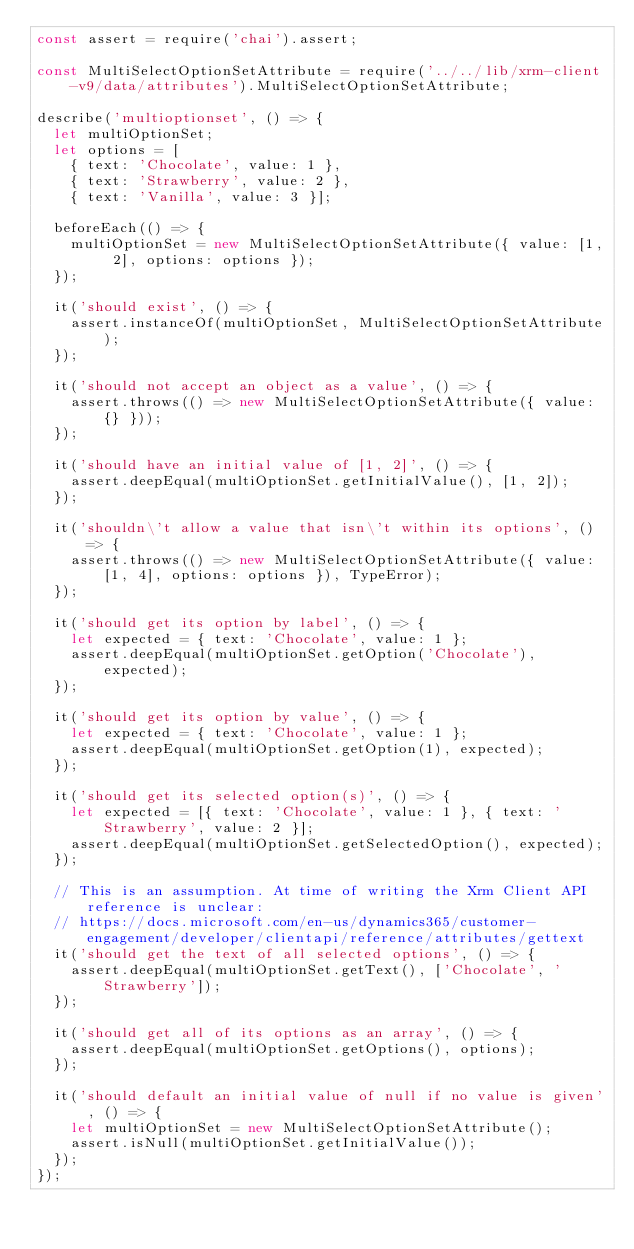Convert code to text. <code><loc_0><loc_0><loc_500><loc_500><_JavaScript_>const assert = require('chai').assert;

const MultiSelectOptionSetAttribute = require('../../lib/xrm-client-v9/data/attributes').MultiSelectOptionSetAttribute;

describe('multioptionset', () => {
  let multiOptionSet;
  let options = [
    { text: 'Chocolate', value: 1 },
    { text: 'Strawberry', value: 2 },
    { text: 'Vanilla', value: 3 }];

  beforeEach(() => {
    multiOptionSet = new MultiSelectOptionSetAttribute({ value: [1, 2], options: options });
  });

  it('should exist', () => {
    assert.instanceOf(multiOptionSet, MultiSelectOptionSetAttribute);
  });

  it('should not accept an object as a value', () => {
    assert.throws(() => new MultiSelectOptionSetAttribute({ value: {} }));
  });

  it('should have an initial value of [1, 2]', () => {
    assert.deepEqual(multiOptionSet.getInitialValue(), [1, 2]);
  });

  it('shouldn\'t allow a value that isn\'t within its options', () => {
    assert.throws(() => new MultiSelectOptionSetAttribute({ value: [1, 4], options: options }), TypeError);
  });

  it('should get its option by label', () => {
    let expected = { text: 'Chocolate', value: 1 };
    assert.deepEqual(multiOptionSet.getOption('Chocolate'), expected);
  });

  it('should get its option by value', () => {
    let expected = { text: 'Chocolate', value: 1 };
    assert.deepEqual(multiOptionSet.getOption(1), expected);
  });

  it('should get its selected option(s)', () => {
    let expected = [{ text: 'Chocolate', value: 1 }, { text: 'Strawberry', value: 2 }];
    assert.deepEqual(multiOptionSet.getSelectedOption(), expected);
  });

  // This is an assumption. At time of writing the Xrm Client API reference is unclear:
  // https://docs.microsoft.com/en-us/dynamics365/customer-engagement/developer/clientapi/reference/attributes/gettext
  it('should get the text of all selected options', () => {
    assert.deepEqual(multiOptionSet.getText(), ['Chocolate', 'Strawberry']);
  });

  it('should get all of its options as an array', () => {
    assert.deepEqual(multiOptionSet.getOptions(), options);
  });

  it('should default an initial value of null if no value is given', () => {
    let multiOptionSet = new MultiSelectOptionSetAttribute();
    assert.isNull(multiOptionSet.getInitialValue());
  });
});
</code> 